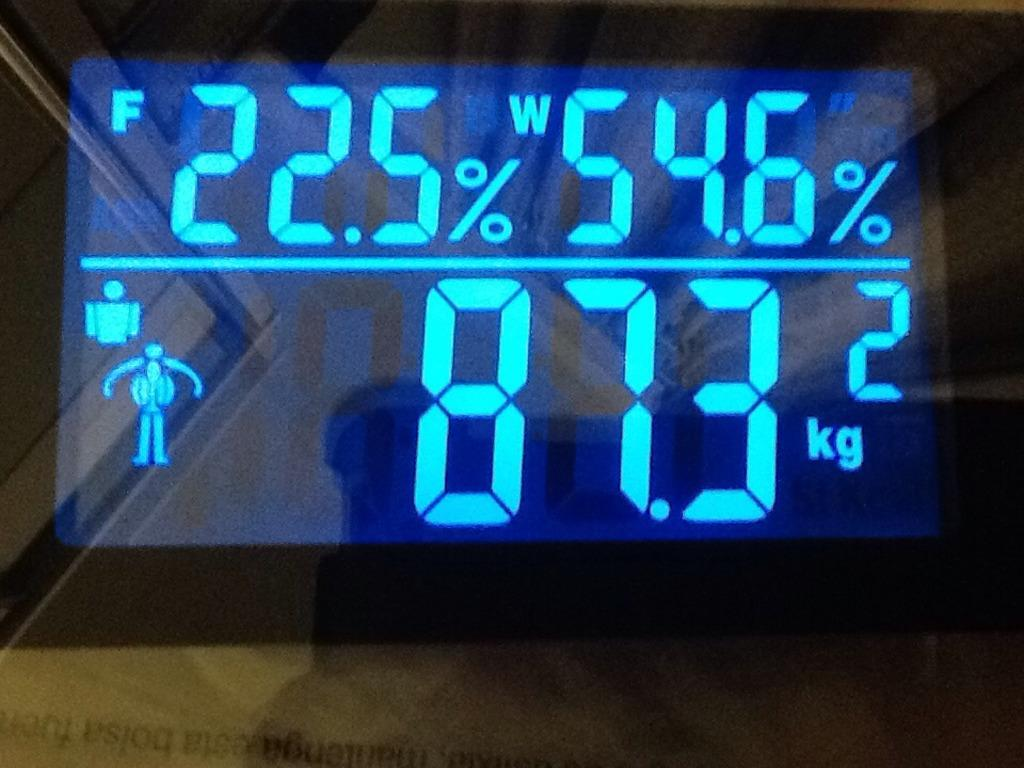<image>
Present a compact description of the photo's key features. Digital screen or monitor showing the weight at 87.3 kg 